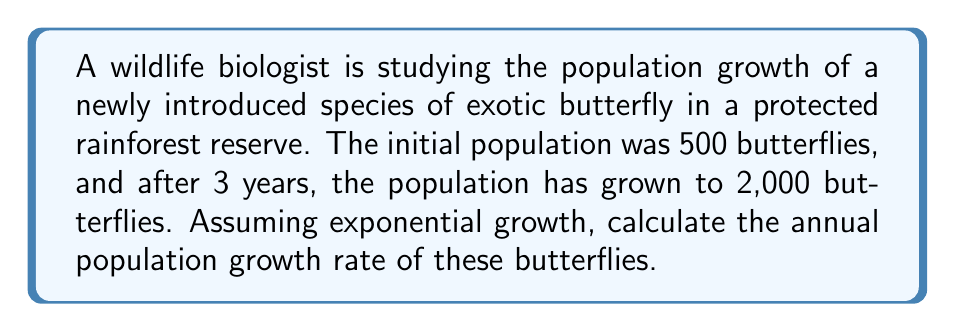Provide a solution to this math problem. To solve this problem, we'll use the exponential growth model:

$$N(t) = N_0 \cdot e^{rt}$$

Where:
$N(t)$ is the population at time $t$
$N_0$ is the initial population
$e$ is Euler's number (approximately 2.71828)
$r$ is the growth rate
$t$ is the time elapsed

We know:
$N_0 = 500$ (initial population)
$N(3) = 2000$ (population after 3 years)
$t = 3$ years

Let's substitute these values into the equation:

$$2000 = 500 \cdot e^{r \cdot 3}$$

Now, let's solve for $r$:

1) Divide both sides by 500:
   $$4 = e^{3r}$$

2) Take the natural logarithm of both sides:
   $$\ln(4) = \ln(e^{3r})$$

3) Simplify the right side using the property of logarithms:
   $$\ln(4) = 3r$$

4) Divide both sides by 3:
   $$\frac{\ln(4)}{3} = r$$

5) Calculate the value:
   $$r \approx 0.4621$$

Therefore, the annual population growth rate is approximately 0.4621 or 46.21%.
Answer: The annual population growth rate of the butterflies is approximately 0.4621 or 46.21%. 